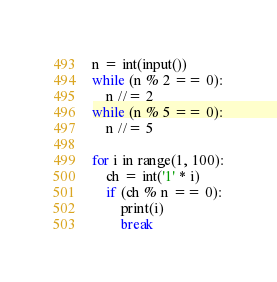Convert code to text. <code><loc_0><loc_0><loc_500><loc_500><_Python_>n = int(input())
while (n % 2 == 0):
    n //= 2
while (n % 5 == 0):
    n //= 5

for i in range(1, 100):
    ch = int('1' * i)
    if (ch % n == 0):
        print(i)
        break</code> 